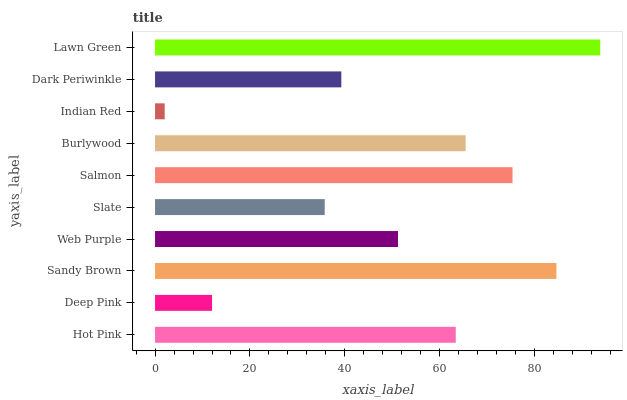Is Indian Red the minimum?
Answer yes or no. Yes. Is Lawn Green the maximum?
Answer yes or no. Yes. Is Deep Pink the minimum?
Answer yes or no. No. Is Deep Pink the maximum?
Answer yes or no. No. Is Hot Pink greater than Deep Pink?
Answer yes or no. Yes. Is Deep Pink less than Hot Pink?
Answer yes or no. Yes. Is Deep Pink greater than Hot Pink?
Answer yes or no. No. Is Hot Pink less than Deep Pink?
Answer yes or no. No. Is Hot Pink the high median?
Answer yes or no. Yes. Is Web Purple the low median?
Answer yes or no. Yes. Is Lawn Green the high median?
Answer yes or no. No. Is Burlywood the low median?
Answer yes or no. No. 